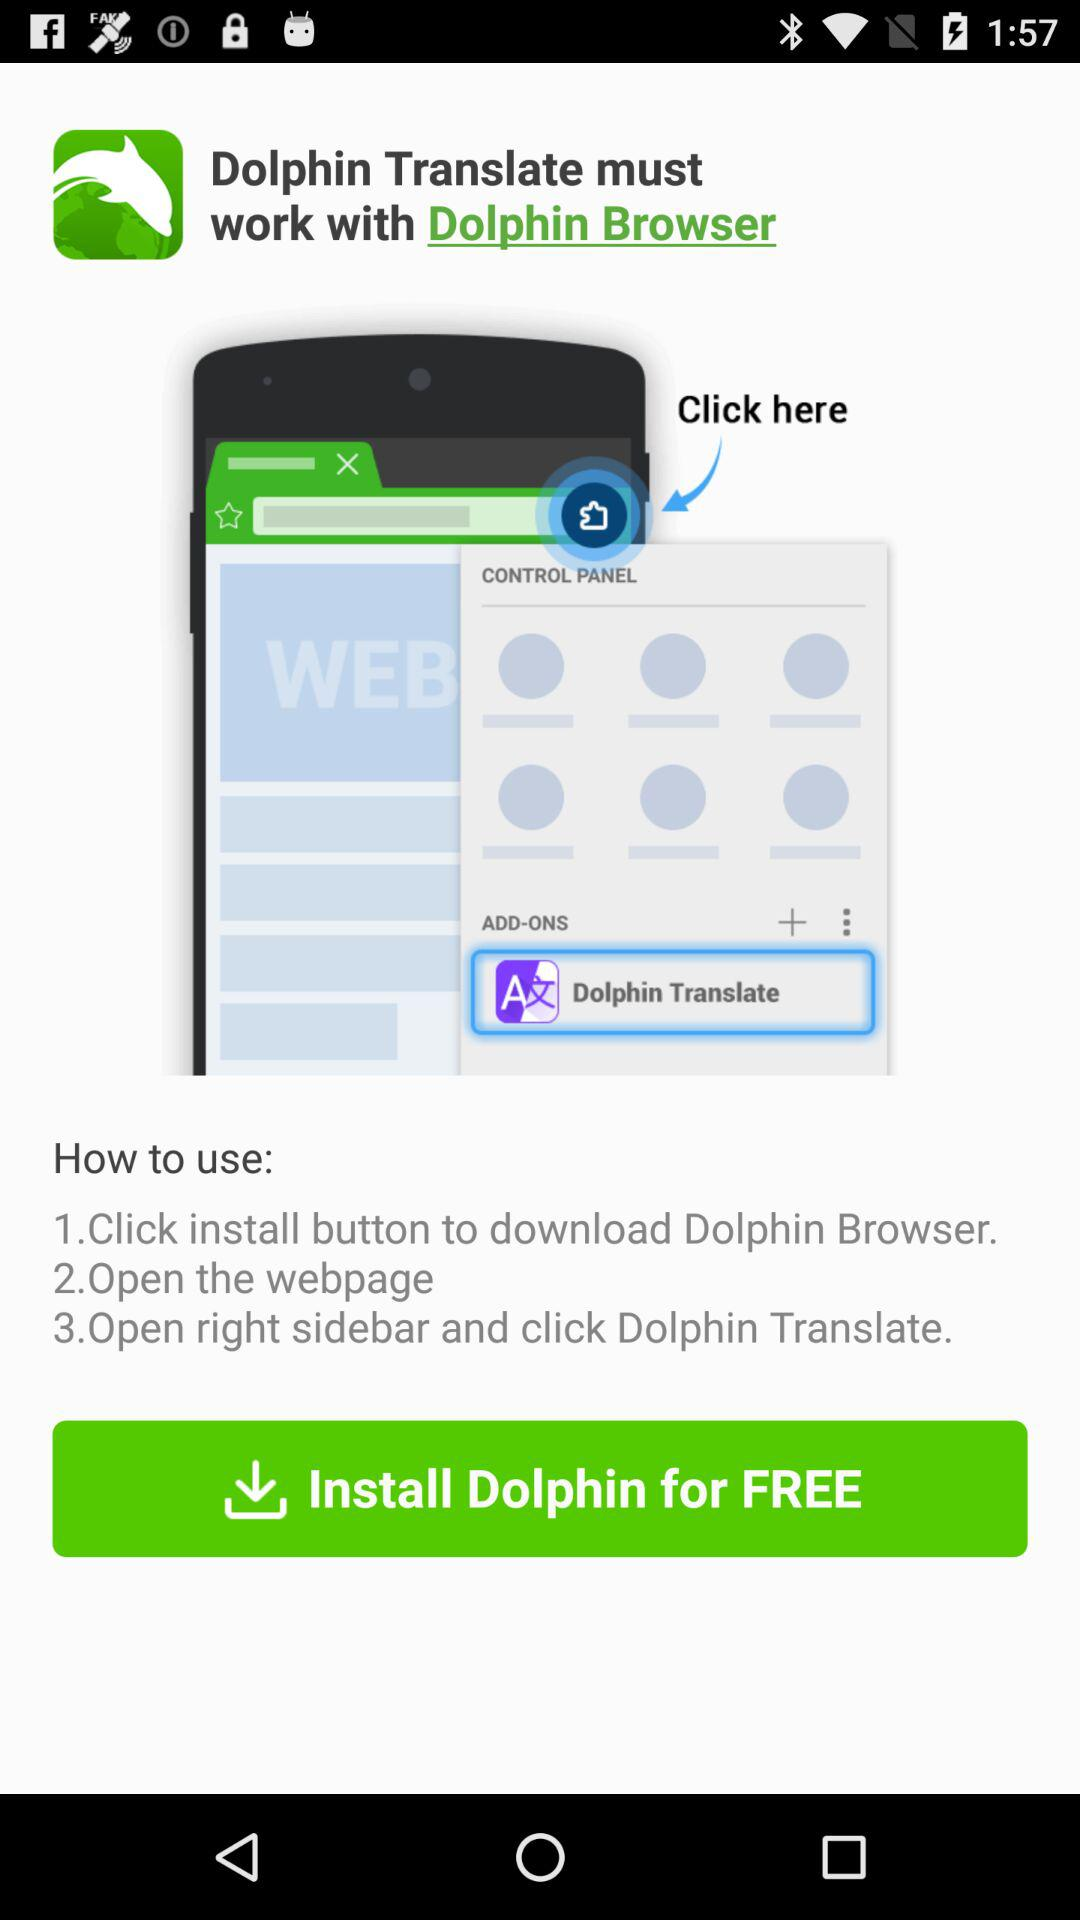How many steps are there in the instructions?
Answer the question using a single word or phrase. 3 